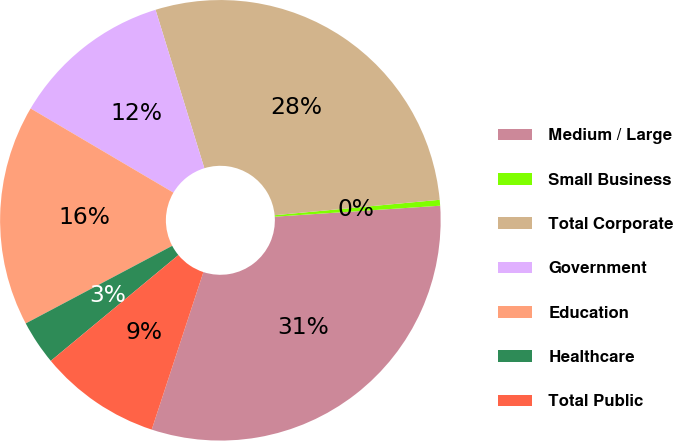Convert chart. <chart><loc_0><loc_0><loc_500><loc_500><pie_chart><fcel>Medium / Large<fcel>Small Business<fcel>Total Corporate<fcel>Government<fcel>Education<fcel>Healthcare<fcel>Total Public<nl><fcel>31.1%<fcel>0.43%<fcel>28.27%<fcel>11.77%<fcel>16.23%<fcel>3.26%<fcel>8.94%<nl></chart> 